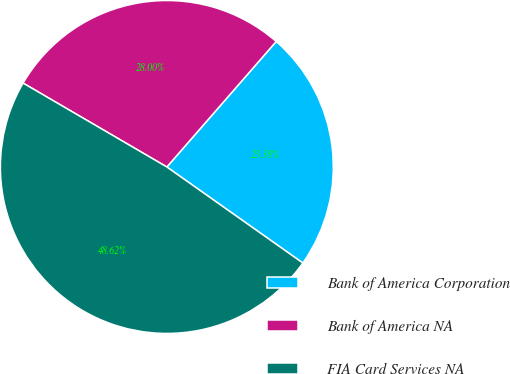Convert chart to OTSL. <chart><loc_0><loc_0><loc_500><loc_500><pie_chart><fcel>Bank of America Corporation<fcel>Bank of America NA<fcel>FIA Card Services NA<nl><fcel>23.38%<fcel>28.0%<fcel>48.62%<nl></chart> 